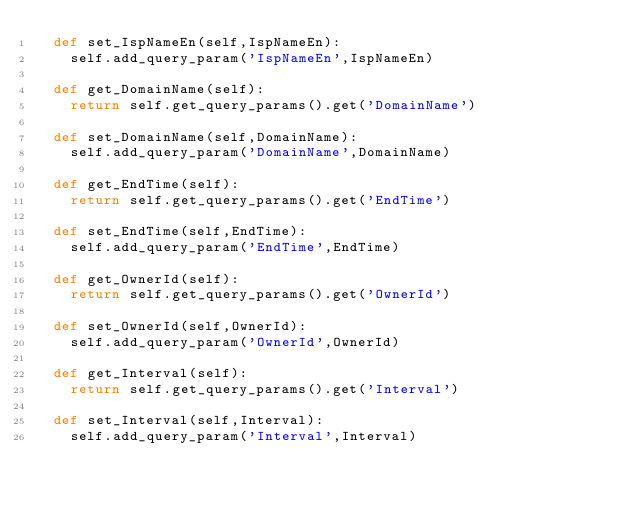Convert code to text. <code><loc_0><loc_0><loc_500><loc_500><_Python_>	def set_IspNameEn(self,IspNameEn):
		self.add_query_param('IspNameEn',IspNameEn)

	def get_DomainName(self):
		return self.get_query_params().get('DomainName')

	def set_DomainName(self,DomainName):
		self.add_query_param('DomainName',DomainName)

	def get_EndTime(self):
		return self.get_query_params().get('EndTime')

	def set_EndTime(self,EndTime):
		self.add_query_param('EndTime',EndTime)

	def get_OwnerId(self):
		return self.get_query_params().get('OwnerId')

	def set_OwnerId(self,OwnerId):
		self.add_query_param('OwnerId',OwnerId)

	def get_Interval(self):
		return self.get_query_params().get('Interval')

	def set_Interval(self,Interval):
		self.add_query_param('Interval',Interval)</code> 